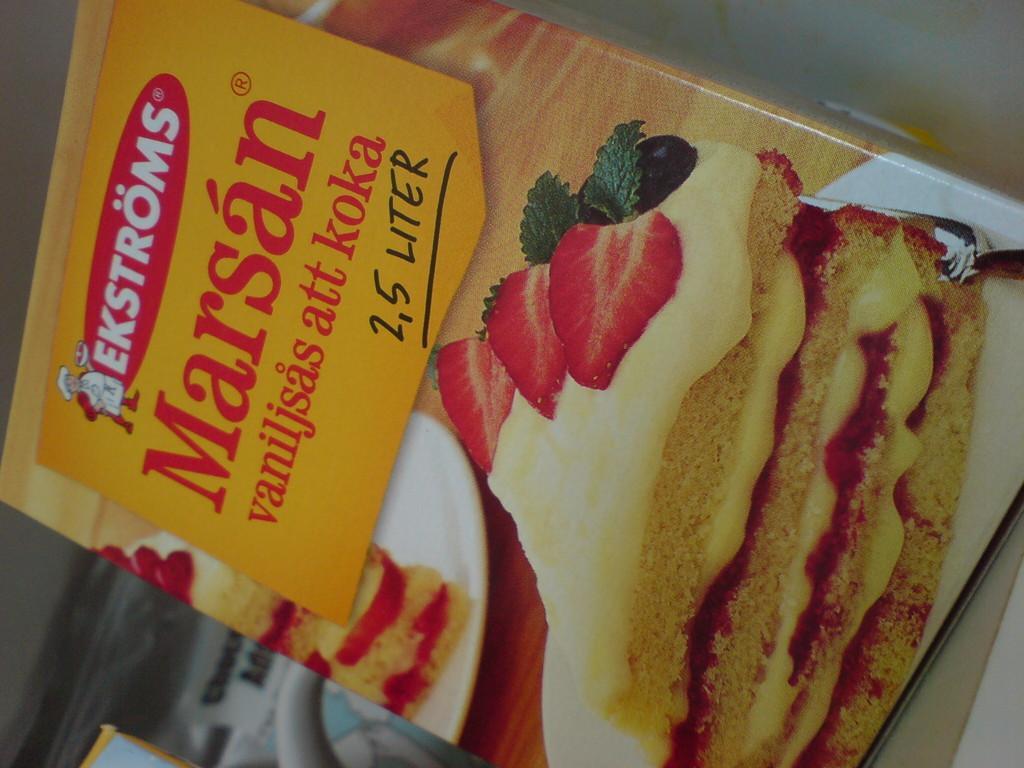Can you describe this image briefly? In this image there is a box having a picture of few breads stuffed with cream and topped with strawberry slices on it which is on the plate. Top of box there is some text. 